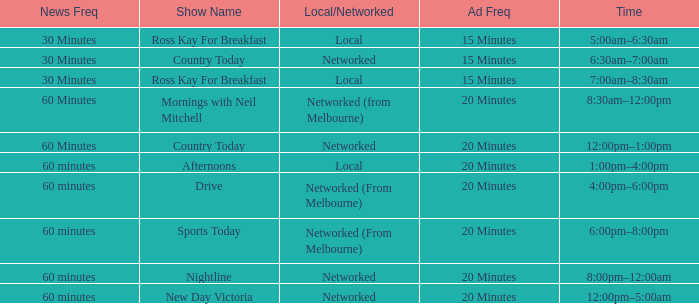What News Freq has a Time of 1:00pm–4:00pm? 60 minutes. 